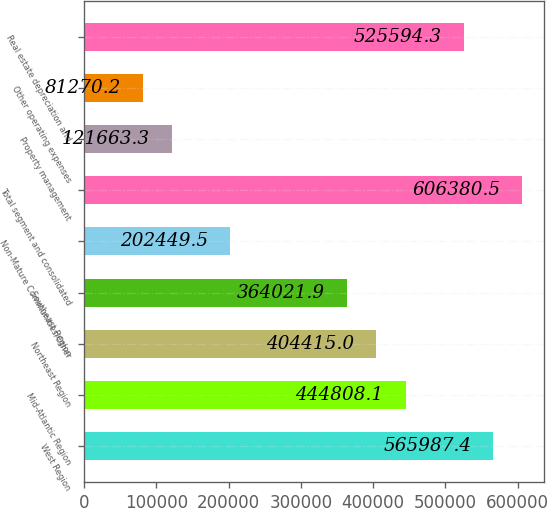Convert chart to OTSL. <chart><loc_0><loc_0><loc_500><loc_500><bar_chart><fcel>West Region<fcel>Mid-Atlantic Region<fcel>Northeast Region<fcel>Southeast Region<fcel>Non-Mature Communities/Other<fcel>Total segment and consolidated<fcel>Property management<fcel>Other operating expenses<fcel>Real estate depreciation and<nl><fcel>565987<fcel>444808<fcel>404415<fcel>364022<fcel>202450<fcel>606380<fcel>121663<fcel>81270.2<fcel>525594<nl></chart> 